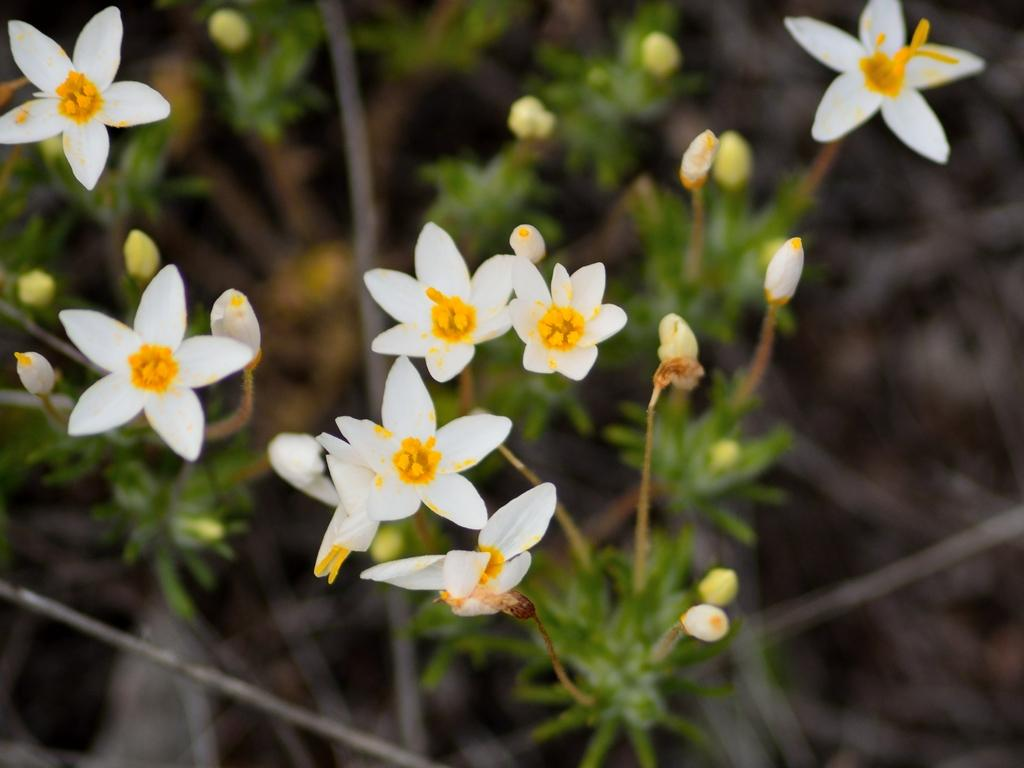What type of living organisms can be seen in the image? Plants can be seen in the image. What specific features are present on the plants? The plants have flowers, and the flowers are in white color. Are there any unopened flower parts visible on the plants? Yes, there are buds on the plants. How would you describe the background of the image? The background of the image is blurred. Can you tell me how many leaves are connected to the wire in the image? There is no wire or leaves present in the image; it features plants with flowers and buds. What type of family can be seen interacting with the plants in the image? There is no family present in the image; it only shows plants with flowers and buds. 